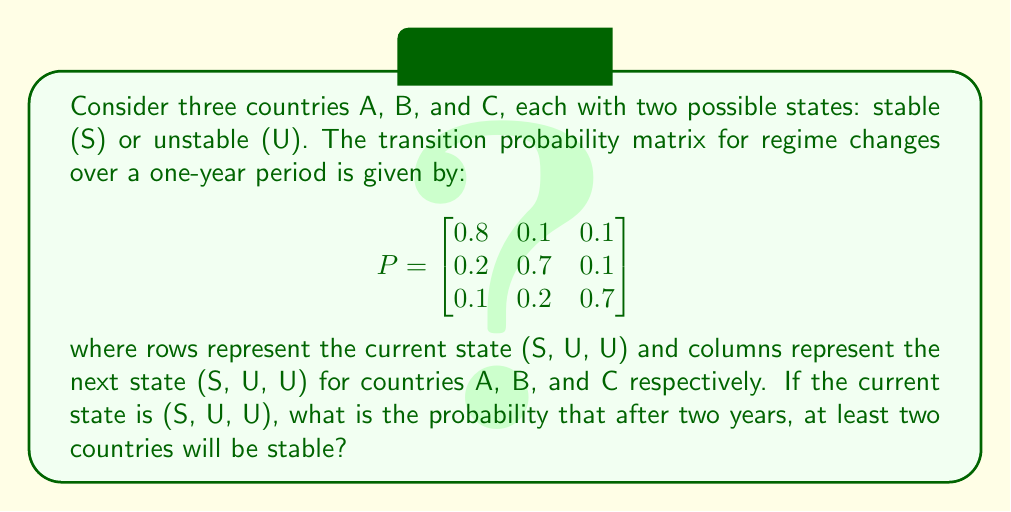Show me your answer to this math problem. To solve this problem, we need to use Markov chains and matrix multiplication. Let's follow these steps:

1) First, we need to find the state after one year. The initial state vector is:
   $$v_0 = \begin{bmatrix} 1 \\ 0 \\ 0 \end{bmatrix}$$

2) After one year, the state vector will be:
   $$v_1 = P \cdot v_0 = \begin{bmatrix}
   0.8 & 0.1 & 0.1 \\
   0.2 & 0.7 & 0.1 \\
   0.1 & 0.2 & 0.7
   \end{bmatrix} \cdot \begin{bmatrix} 1 \\ 0 \\ 0 \end{bmatrix} = \begin{bmatrix} 0.8 \\ 0.2 \\ 0.1 \end{bmatrix}$$

3) For the second year, we multiply again:
   $$v_2 = P \cdot v_1 = \begin{bmatrix}
   0.8 & 0.1 & 0.1 \\
   0.2 & 0.7 & 0.1 \\
   0.1 & 0.2 & 0.7
   \end{bmatrix} \cdot \begin{bmatrix} 0.8 \\ 0.2 \\ 0.1 \end{bmatrix} = \begin{bmatrix} 0.67 \\ 0.23 \\ 0.10 \end{bmatrix}$$

4) Now, we need to calculate the probability of at least two countries being stable. This can happen in three ways:
   - All three countries are stable: $(0.67)^3$
   - Exactly two countries are stable: $3 \cdot (0.67)^2 \cdot (0.33)$

5) Adding these probabilities:
   $P(\text{at least two stable}) = (0.67)^3 + 3 \cdot (0.67)^2 \cdot (0.33)$
   $= 0.300763 + 0.446985 = 0.747748$

Therefore, the probability that after two years, at least two countries will be stable is approximately 0.7477 or 74.77%.
Answer: 0.7477 